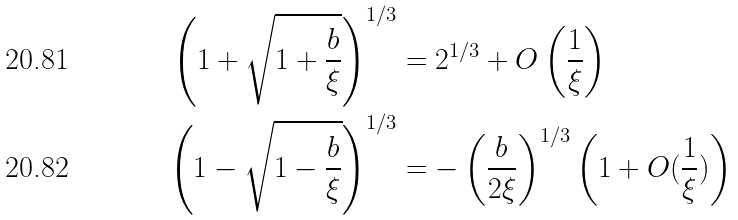Convert formula to latex. <formula><loc_0><loc_0><loc_500><loc_500>\left ( 1 + \sqrt { 1 + \frac { b } { \xi } } \right ) ^ { 1 / 3 } & = 2 ^ { 1 / 3 } + O \left ( \frac { 1 } { \xi } \right ) \\ \left ( 1 - \sqrt { 1 - \frac { b } { \xi } } \right ) ^ { 1 / 3 } & = - \left ( \frac { b } { 2 \xi } \right ) ^ { 1 / 3 } \left ( 1 + O ( \frac { 1 } { \xi } ) \right )</formula> 